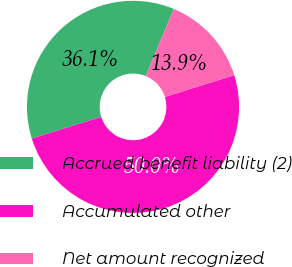<chart> <loc_0><loc_0><loc_500><loc_500><pie_chart><fcel>Accrued benefit liability (2)<fcel>Accumulated other<fcel>Net amount recognized<nl><fcel>36.11%<fcel>50.0%<fcel>13.89%<nl></chart> 